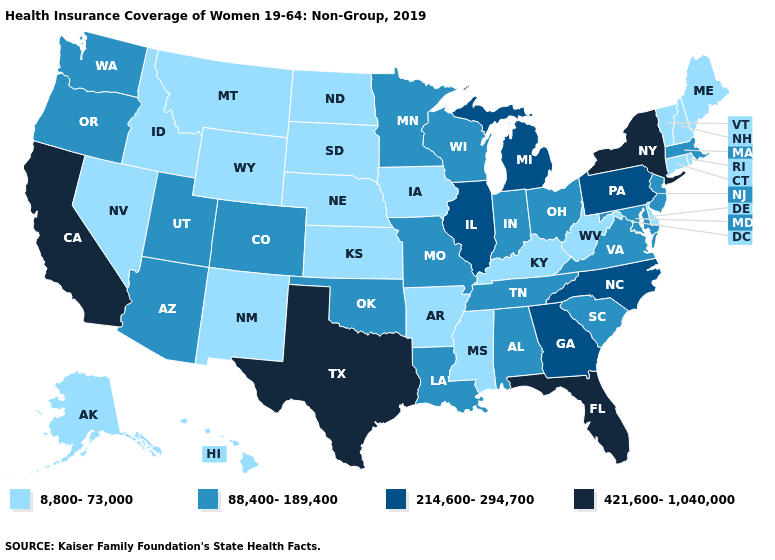Name the states that have a value in the range 88,400-189,400?
Give a very brief answer. Alabama, Arizona, Colorado, Indiana, Louisiana, Maryland, Massachusetts, Minnesota, Missouri, New Jersey, Ohio, Oklahoma, Oregon, South Carolina, Tennessee, Utah, Virginia, Washington, Wisconsin. What is the value of Texas?
Keep it brief. 421,600-1,040,000. What is the value of Illinois?
Quick response, please. 214,600-294,700. Among the states that border New Hampshire , which have the highest value?
Be succinct. Massachusetts. What is the lowest value in the South?
Answer briefly. 8,800-73,000. Name the states that have a value in the range 214,600-294,700?
Keep it brief. Georgia, Illinois, Michigan, North Carolina, Pennsylvania. Which states have the lowest value in the MidWest?
Write a very short answer. Iowa, Kansas, Nebraska, North Dakota, South Dakota. Name the states that have a value in the range 421,600-1,040,000?
Short answer required. California, Florida, New York, Texas. Does the first symbol in the legend represent the smallest category?
Quick response, please. Yes. What is the highest value in the USA?
Quick response, please. 421,600-1,040,000. What is the value of North Carolina?
Quick response, please. 214,600-294,700. Does the map have missing data?
Be succinct. No. Which states have the lowest value in the USA?
Answer briefly. Alaska, Arkansas, Connecticut, Delaware, Hawaii, Idaho, Iowa, Kansas, Kentucky, Maine, Mississippi, Montana, Nebraska, Nevada, New Hampshire, New Mexico, North Dakota, Rhode Island, South Dakota, Vermont, West Virginia, Wyoming. Which states hav the highest value in the West?
Short answer required. California. Name the states that have a value in the range 214,600-294,700?
Answer briefly. Georgia, Illinois, Michigan, North Carolina, Pennsylvania. 